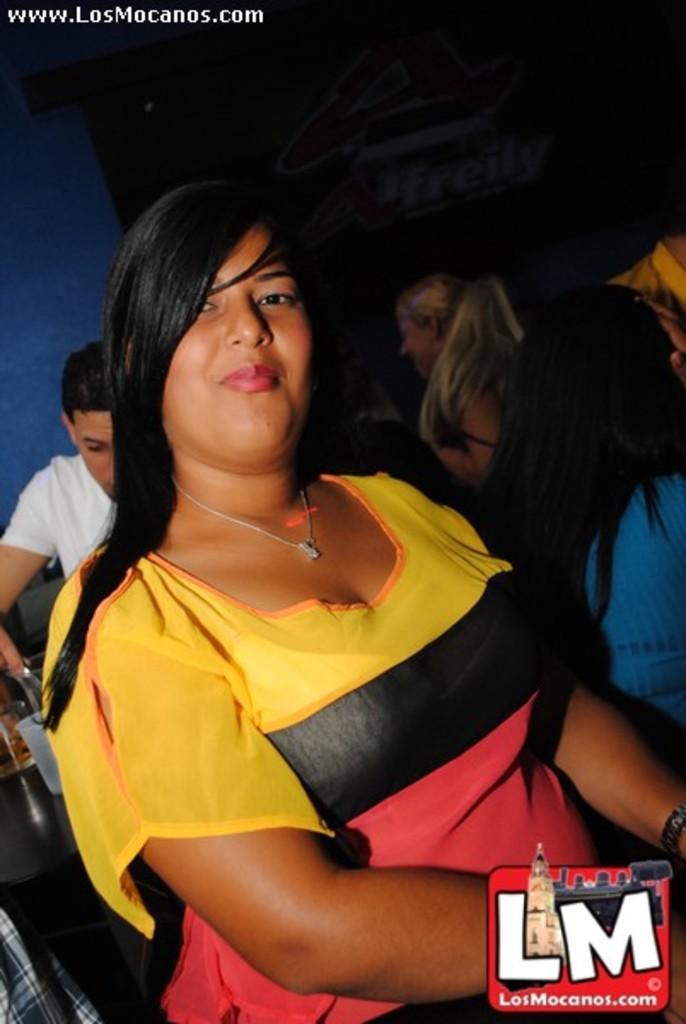Could you give a brief overview of what you see in this image? In the picture we can see a photograph of a woman standing and she is with T-shirt with a color on it yellow, black and pink and with a necklace and loose hair and behind her we can see a man with white T-shirt near the table on it we can see a glass with wine and some other glass on it and beside him we can see some girls are standing and in the background we can see a wall in the dark. 